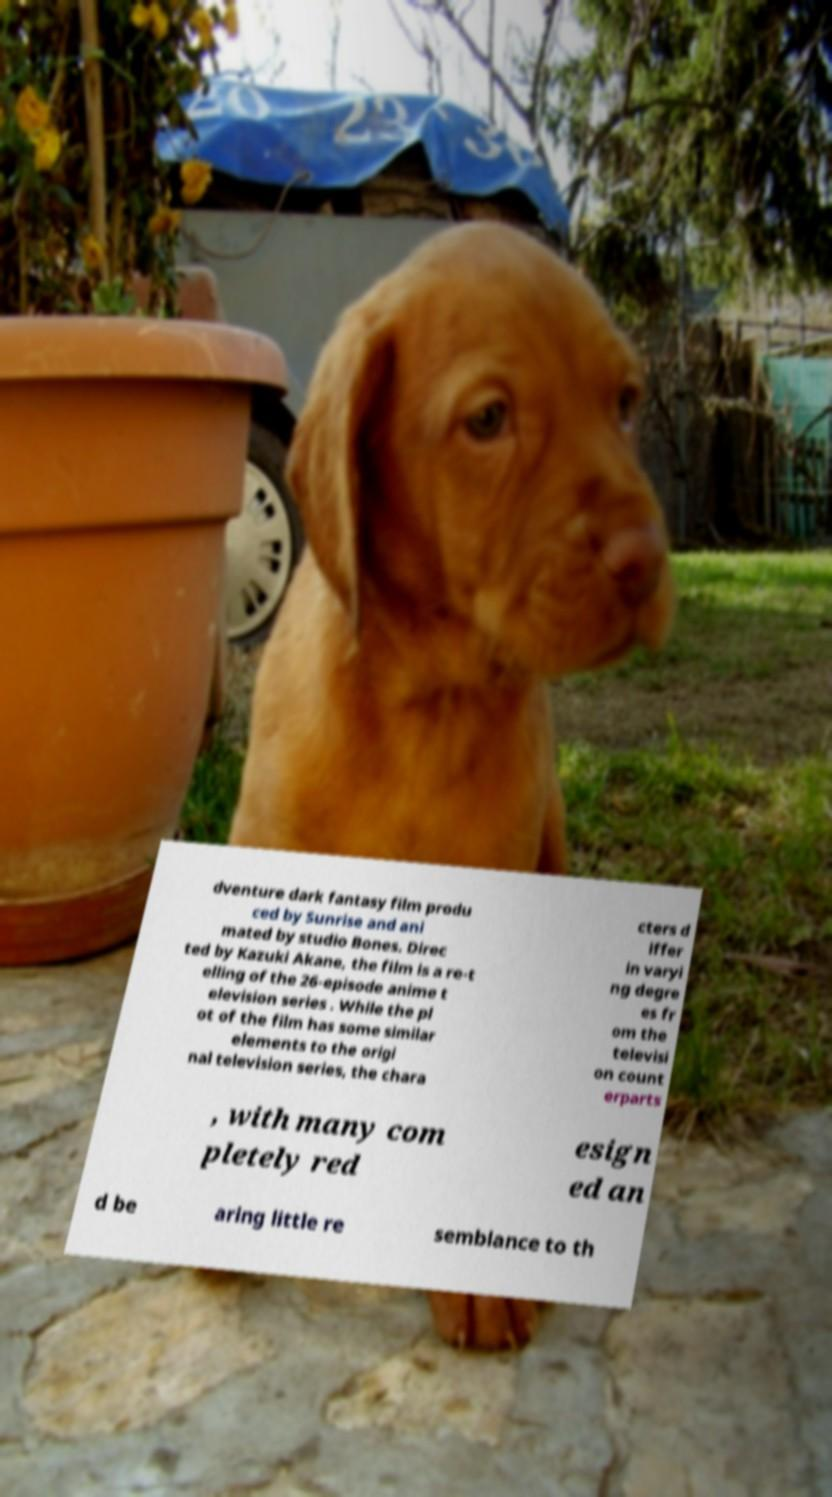Can you read and provide the text displayed in the image?This photo seems to have some interesting text. Can you extract and type it out for me? dventure dark fantasy film produ ced by Sunrise and ani mated by studio Bones. Direc ted by Kazuki Akane, the film is a re-t elling of the 26-episode anime t elevision series . While the pl ot of the film has some similar elements to the origi nal television series, the chara cters d iffer in varyi ng degre es fr om the televisi on count erparts , with many com pletely red esign ed an d be aring little re semblance to th 